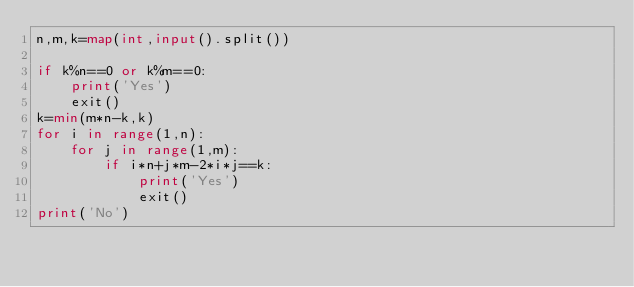Convert code to text. <code><loc_0><loc_0><loc_500><loc_500><_Python_>n,m,k=map(int,input().split())

if k%n==0 or k%m==0:
    print('Yes')
    exit()
k=min(m*n-k,k)
for i in range(1,n):
    for j in range(1,m):
        if i*n+j*m-2*i*j==k:
            print('Yes')
            exit()
print('No')</code> 